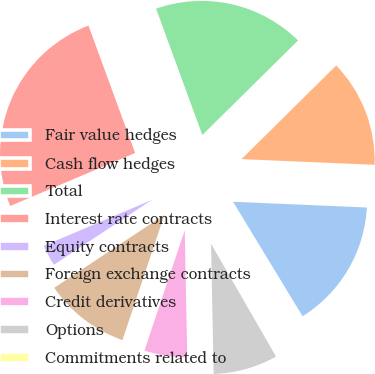<chart> <loc_0><loc_0><loc_500><loc_500><pie_chart><fcel>Fair value hedges<fcel>Cash flow hedges<fcel>Total<fcel>Interest rate contracts<fcel>Equity contracts<fcel>Foreign exchange contracts<fcel>Credit derivatives<fcel>Options<fcel>Commitments related to<nl><fcel>15.63%<fcel>13.09%<fcel>18.18%<fcel>25.81%<fcel>2.91%<fcel>10.55%<fcel>5.46%<fcel>8.0%<fcel>0.37%<nl></chart> 